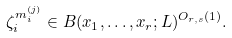Convert formula to latex. <formula><loc_0><loc_0><loc_500><loc_500>\zeta _ { i } ^ { m _ { i } ^ { ( j ) } } \in B ( x _ { 1 } , \dots , x _ { r } ; L ) ^ { O _ { r , s } ( 1 ) } .</formula> 